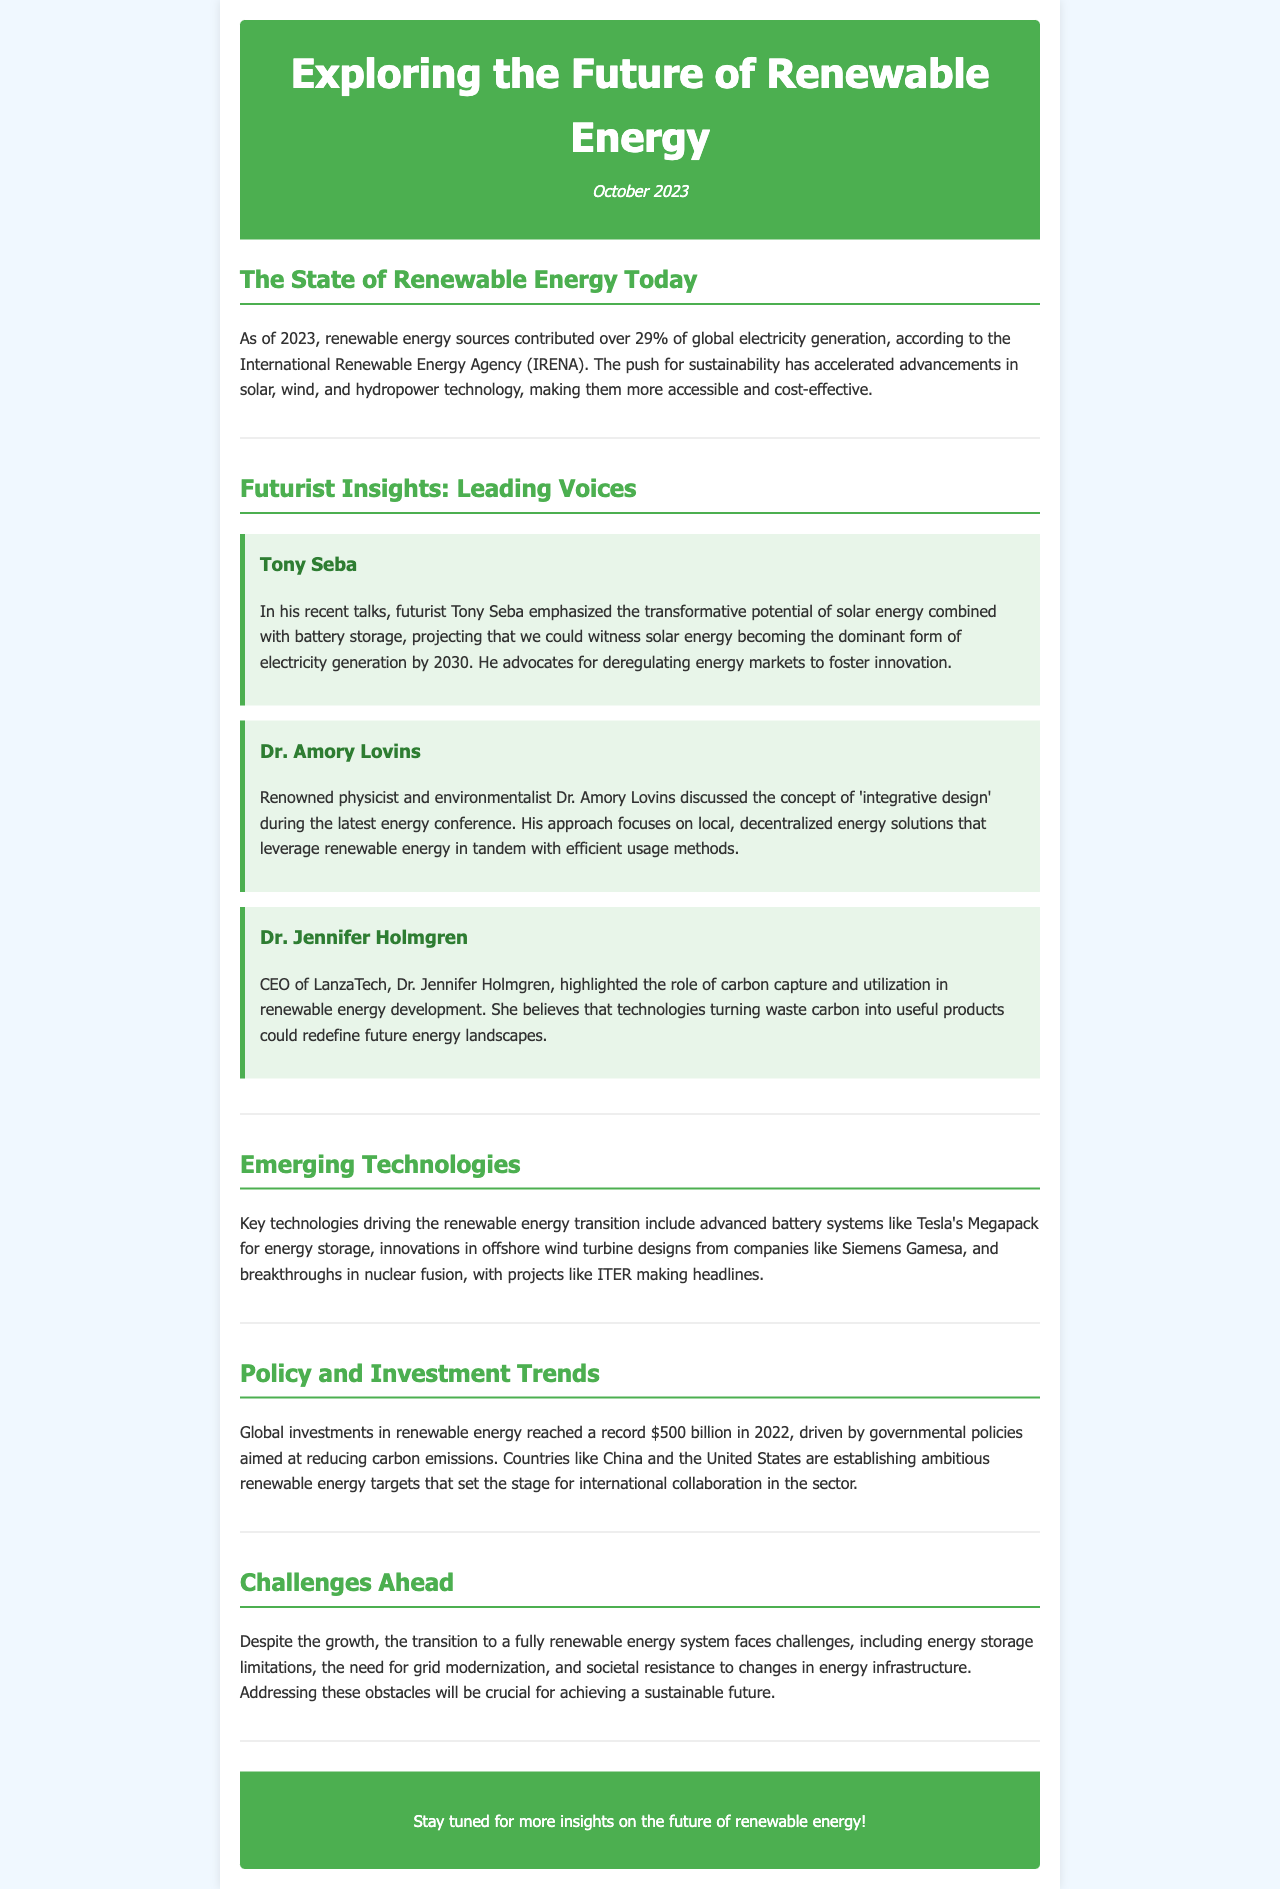what percentage of global electricity generation comes from renewable energy as of 2023? The document states that renewable energy sources contributed over 29% of global electricity generation in 2023.
Answer: over 29% who emphasized the potential of solar energy and battery storage? Tony Seba is highlighted in the document as emphasizing the transformative potential of solar energy combined with battery storage.
Answer: Tony Seba what concept did Dr. Amory Lovins discuss? Dr. Amory Lovins discussed the concept of 'integrative design' at the energy conference.
Answer: integrative design how much did global investments in renewable energy reach in 2022? The document states that global investments in renewable energy reached a record $500 billion in 2022.
Answer: $500 billion what is the role of technologies turning waste carbon into useful products according to Dr. Jennifer Holmgren? Dr. Jennifer Holmgren believes that these technologies could redefine future energy landscapes.
Answer: redefine future energy landscapes what are some emerging technologies mentioned in the newsletter? The document lists advanced battery systems, offshore wind turbine designs, and breakthroughs in nuclear fusion as key technologies.
Answer: advanced battery systems, offshore wind turbine designs, nuclear fusion what challenge is mentioned regarding the transition to a renewable energy system? The document mentions energy storage limitations as one of the challenges faced in this transition.
Answer: energy storage limitations what is the main focus of the newsletter? The newsletter focuses on insights from leading futurist scientists regarding the future of renewable energy.
Answer: insights from leading futurist scientists regarding renewable energy 